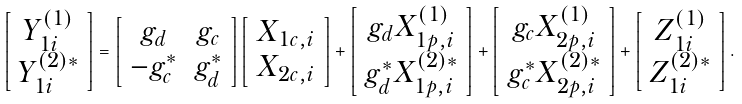Convert formula to latex. <formula><loc_0><loc_0><loc_500><loc_500>\left [ \begin{array} { c } Y _ { 1 i } ^ { ( 1 ) } \\ Y _ { 1 i } ^ { ( 2 ) * } \\ \end{array} \right ] = \left [ \begin{array} { c c } g _ { d } & g _ { c } \\ - g _ { c } ^ { * } & g _ { d } ^ { * } \\ \end{array} \right ] \left [ \begin{array} { c } X _ { 1 c , i } \\ X _ { 2 c , i } \\ \end{array} \right ] + \left [ \begin{array} { c } g _ { d } X _ { 1 p , i } ^ { ( 1 ) } \\ g _ { d } ^ { * } X _ { 1 p , i } ^ { ( 2 ) * } \\ \end{array} \right ] + \left [ \begin{array} { c } g _ { c } X _ { 2 p , i } ^ { ( 1 ) } \\ g _ { c } ^ { * } X _ { 2 p , i } ^ { ( 2 ) * } \\ \end{array} \right ] + \left [ \begin{array} { c } Z _ { 1 i } ^ { ( 1 ) } \\ Z _ { 1 i } ^ { ( 2 ) * } \\ \end{array} \right ] .</formula> 